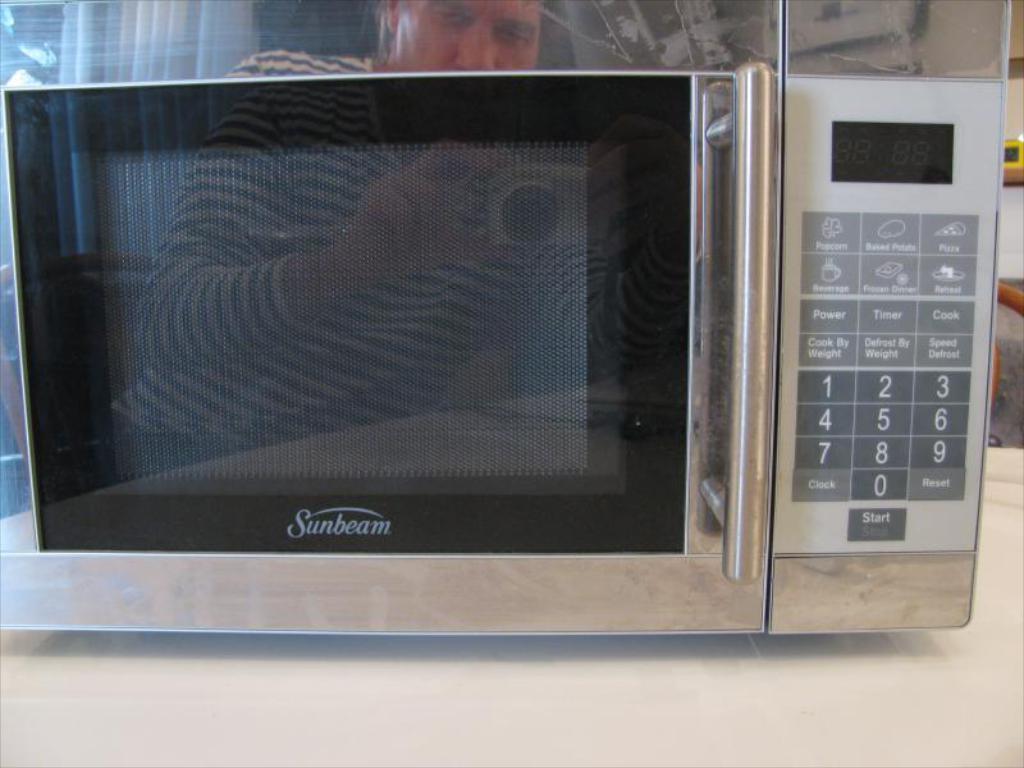What does the top left button do?
Ensure brevity in your answer.  Popcorn. What brand is it?
Ensure brevity in your answer.  Sunbeam. 